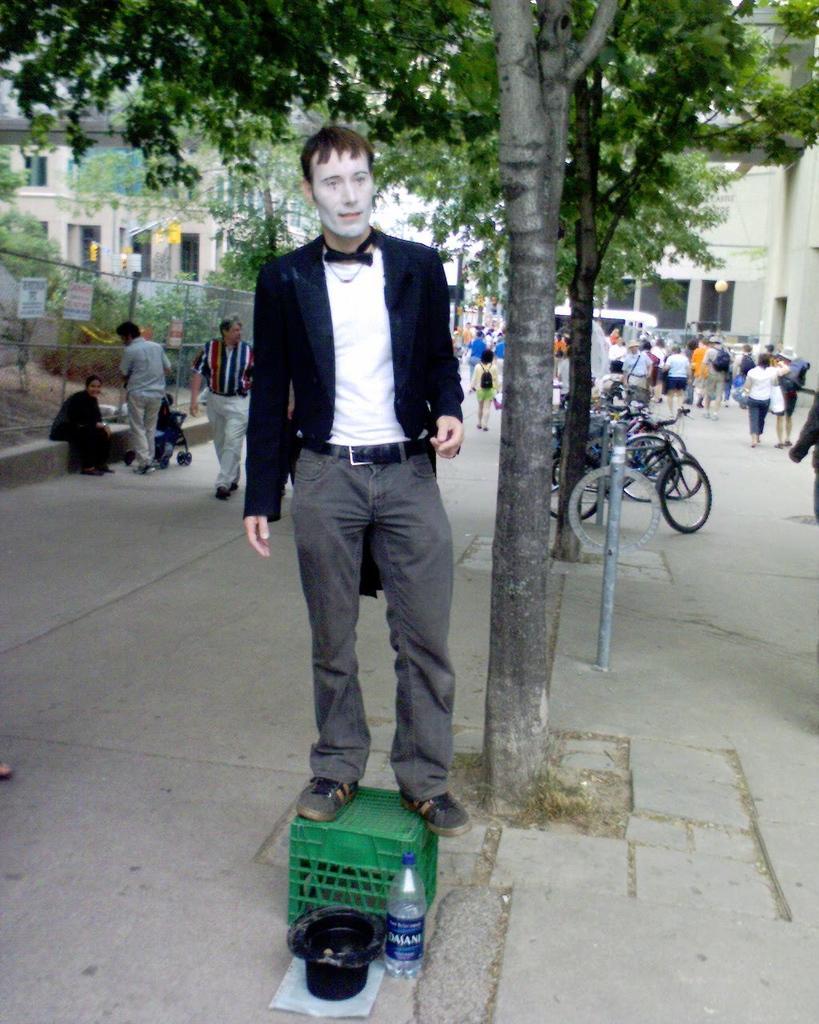In one or two sentences, can you explain what this image depicts? In this image their is a man standing on the stool which is kept on the road,in front of stool there is a cap and an water bottle. To the left side there is a grill. In the background there are people walking. Beside the man there is a tree and cycles. At the top left corner there is a building. 